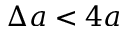<formula> <loc_0><loc_0><loc_500><loc_500>\Delta a < 4 a</formula> 